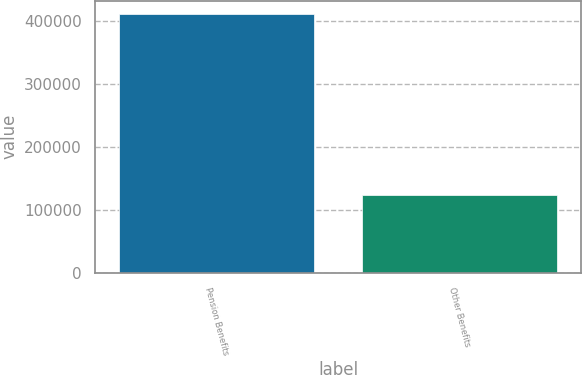Convert chart to OTSL. <chart><loc_0><loc_0><loc_500><loc_500><bar_chart><fcel>Pension Benefits<fcel>Other Benefits<nl><fcel>411204<fcel>123996<nl></chart> 